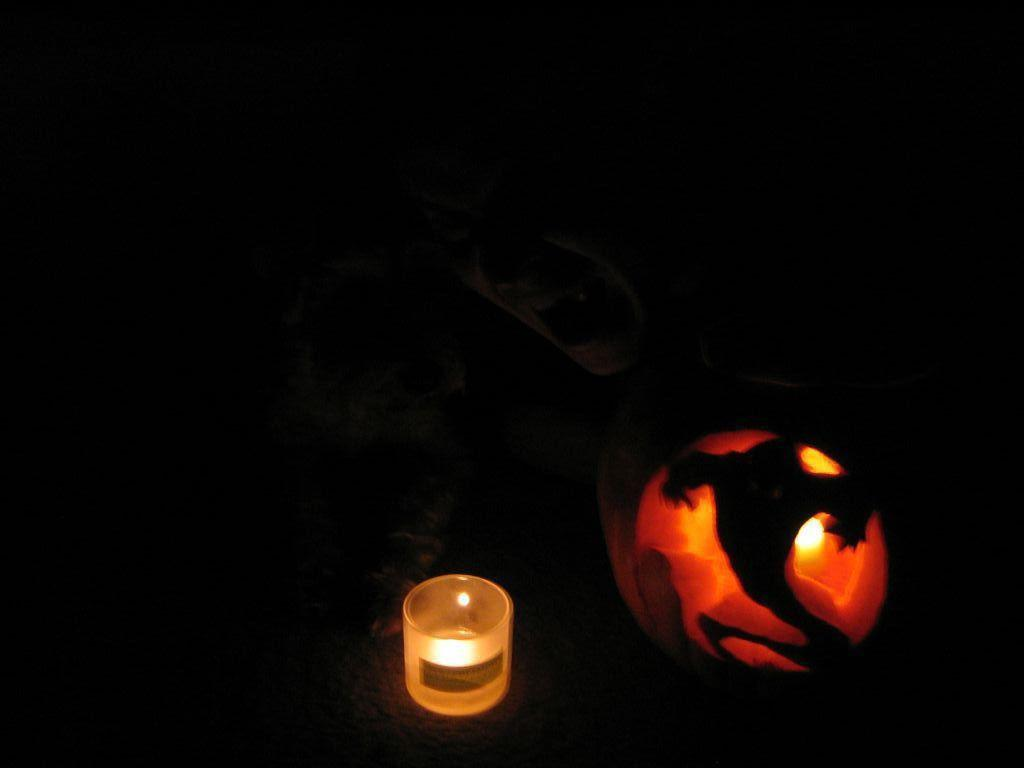What object can be seen in the image? There is a candle in the image. What is the color of the background in the image? The background of the image is dark. What type of motion can be seen in the image? There is no motion visible in the image; it is a still image. What kind of band is playing in the background of the image? There is no band present in the image, as it only features a candle and a dark background. 